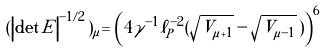Convert formula to latex. <formula><loc_0><loc_0><loc_500><loc_500>( \left | \det E \right | ^ { - 1 / 2 } ) _ { \mu } = \left ( 4 \gamma ^ { - 1 } \ell _ { P } ^ { - 2 } ( \sqrt { V _ { \mu + 1 } } - \sqrt { V _ { \mu - 1 } } \, ) \right ) ^ { 6 }</formula> 